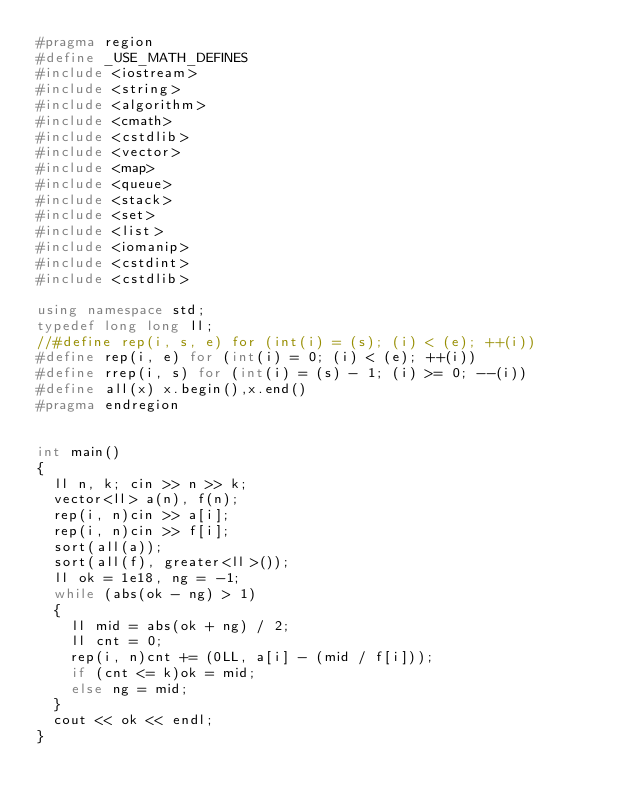<code> <loc_0><loc_0><loc_500><loc_500><_C++_>#pragma region
#define _USE_MATH_DEFINES
#include <iostream>
#include <string>
#include <algorithm>
#include <cmath>
#include <cstdlib>
#include <vector>
#include <map>
#include <queue>
#include <stack>
#include <set>
#include <list>
#include <iomanip>
#include <cstdint>
#include <cstdlib>

using namespace std;
typedef long long ll;
//#define rep(i, s, e) for (int(i) = (s); (i) < (e); ++(i))
#define rep(i, e) for (int(i) = 0; (i) < (e); ++(i))
#define rrep(i, s) for (int(i) = (s) - 1; (i) >= 0; --(i))
#define all(x) x.begin(),x.end()
#pragma endregion


int main()
{
	ll n, k; cin >> n >> k;
	vector<ll> a(n), f(n);
	rep(i, n)cin >> a[i];
	rep(i, n)cin >> f[i];
	sort(all(a));
	sort(all(f), greater<ll>());
	ll ok = 1e18, ng = -1;
	while (abs(ok - ng) > 1)
	{
		ll mid = abs(ok + ng) / 2;
		ll cnt = 0;
		rep(i, n)cnt += (0LL, a[i] - (mid / f[i]));
		if (cnt <= k)ok = mid;
		else ng = mid;
	}
	cout << ok << endl;
}
</code> 